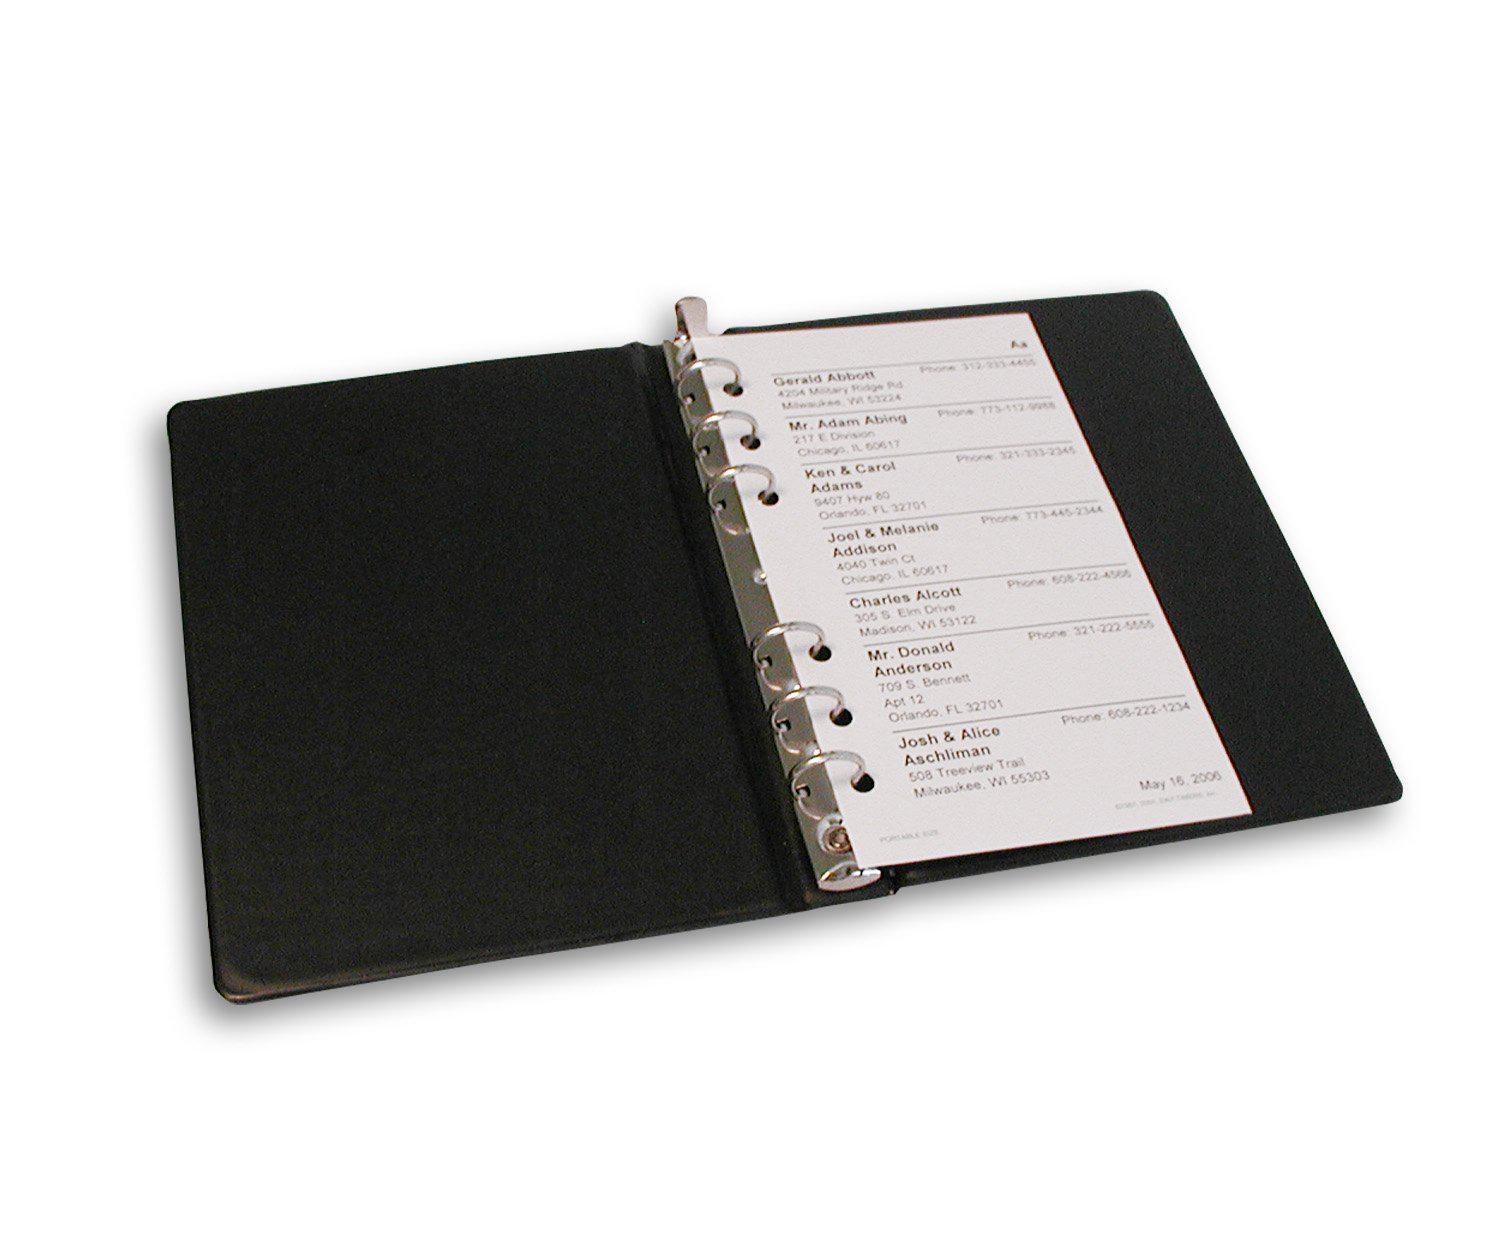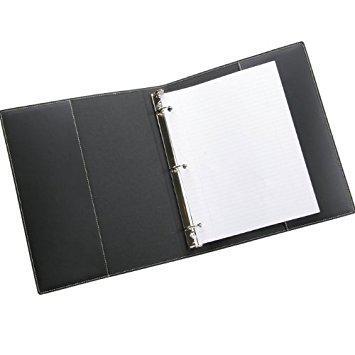The first image is the image on the left, the second image is the image on the right. Evaluate the accuracy of this statement regarding the images: "Left image shows an open binder with paper in it.". Is it true? Answer yes or no. Yes. The first image is the image on the left, the second image is the image on the right. Given the left and right images, does the statement "One image shows a leather notebook both opened and closed, while the second image shows one or more notebooks, but only one opened." hold true? Answer yes or no. No. 